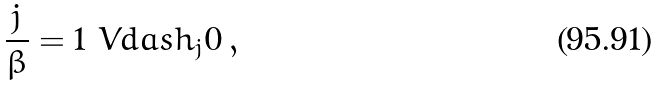<formula> <loc_0><loc_0><loc_500><loc_500>\frac { j } \beta = 1 \ V d a s h _ { j } 0 \, ,</formula> 